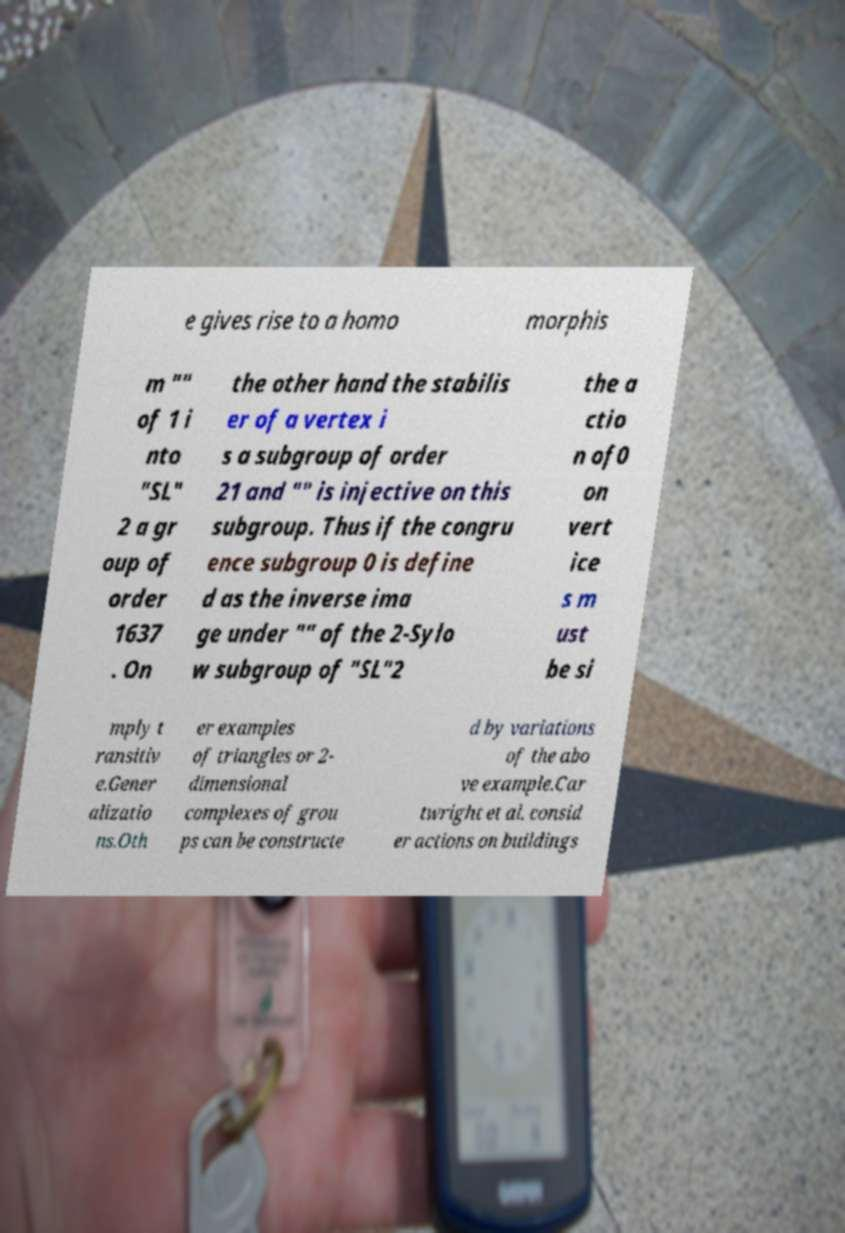I need the written content from this picture converted into text. Can you do that? e gives rise to a homo morphis m "" of 1 i nto "SL" 2 a gr oup of order 1637 . On the other hand the stabilis er of a vertex i s a subgroup of order 21 and "" is injective on this subgroup. Thus if the congru ence subgroup 0 is define d as the inverse ima ge under "" of the 2-Sylo w subgroup of "SL"2 the a ctio n of0 on vert ice s m ust be si mply t ransitiv e.Gener alizatio ns.Oth er examples of triangles or 2- dimensional complexes of grou ps can be constructe d by variations of the abo ve example.Car twright et al. consid er actions on buildings 